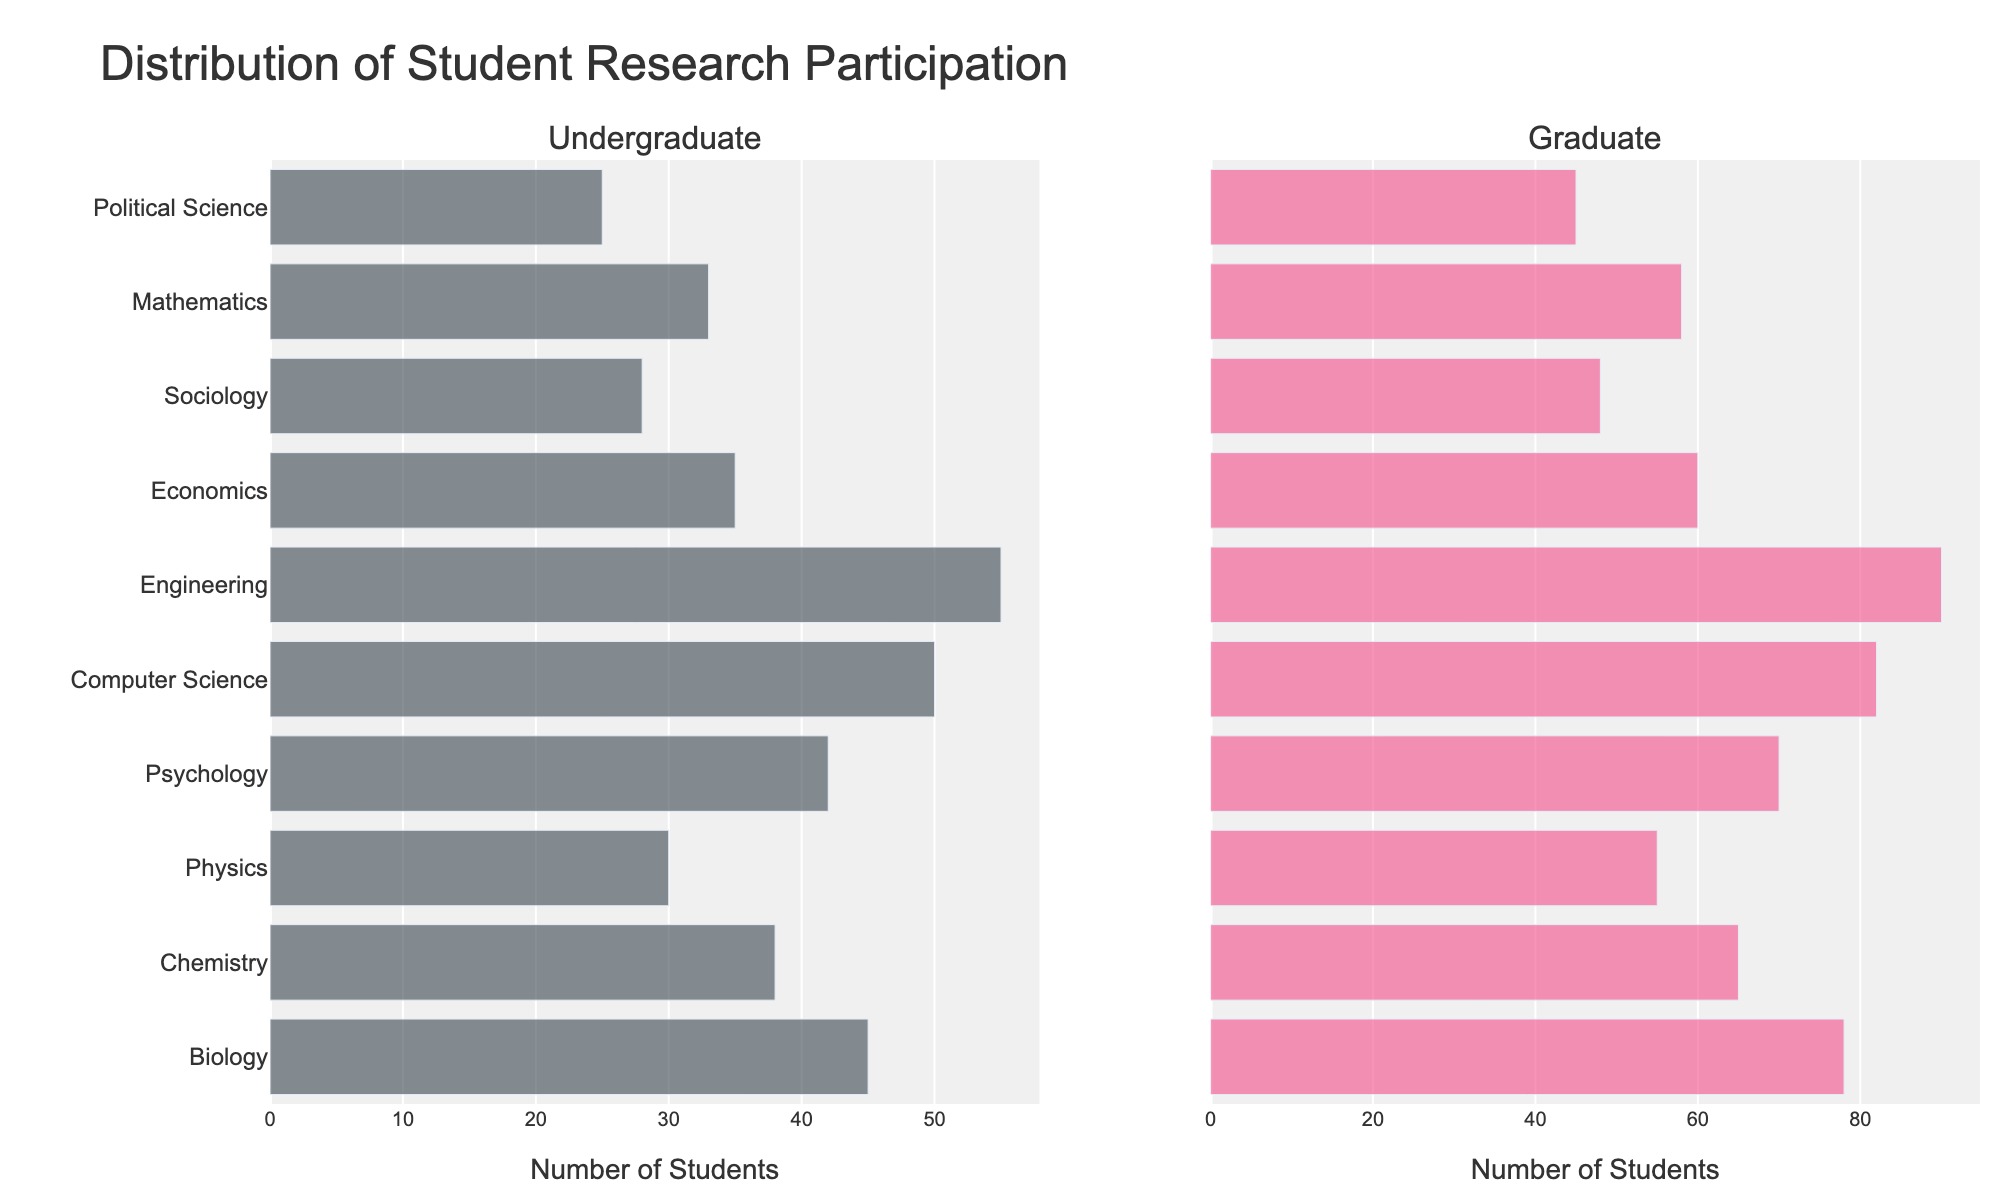what is the total number of undergraduate students in Biology and Chemistry combined? Sum the values for Biology and Chemistry in the undergraduate bar: 45 (Biology) + 38 (Chemistry) = 83
Answer: 83 Which department has the highest number of graduate students? Look for the longest bar in the graduate subplot. The longest bar corresponds to Engineering.
Answer: Engineering Are there more undergraduate students in Psychology or Economics? Compare the lengths of the undergraduate bars for Psychology and Economics. Psychology has 42, which is greater than 35 in Economics.
Answer: Psychology What is the difference in the number of graduate students between Physics and Mathematics? Subtract the number of graduate students in Mathematics from those in Physics: 55 (Physics) - 58 (Mathematics) = 3
Answer: 3 Which department has a higher participation in research among undergraduates: Political Science or Sociology? Compare the length of the undergraduate bars for Political Science and Sociology. Political Science has 25, while Sociology has 28.
Answer: Sociology What is the average number of undergraduate students in Computer Science and Engineering? Add the two values and divide by 2: (50 (Computer Science) + 55 (Engineering)) / 2 = 52.5
Answer: 52.5 Compare the number of graduate students in Biology and Physics. Which one is higher? Compare the lengths of the graduate bars for Biology and Physics. Biology has 78, while Physics has 55.
Answer: Biology What is the overall trend in student research participation from undergraduate to graduate across departments? Observe the general trend by comparing the undergraduate and graduate bars side by side for each department. Most departments have higher numbers in the graduate category.
Answer: Graduate participation is higher Is there any department where the number of undergraduate students exceeds the number of graduate students? Look for bars where the undergraduate bar is longer than the graduate bar. No such bars are present.
Answer: No 